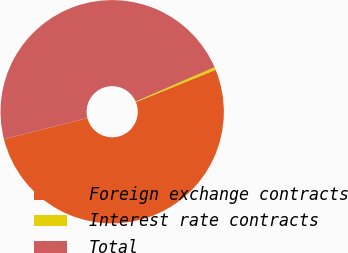Convert chart. <chart><loc_0><loc_0><loc_500><loc_500><pie_chart><fcel>Foreign exchange contracts<fcel>Interest rate contracts<fcel>Total<nl><fcel>52.17%<fcel>0.41%<fcel>47.42%<nl></chart> 